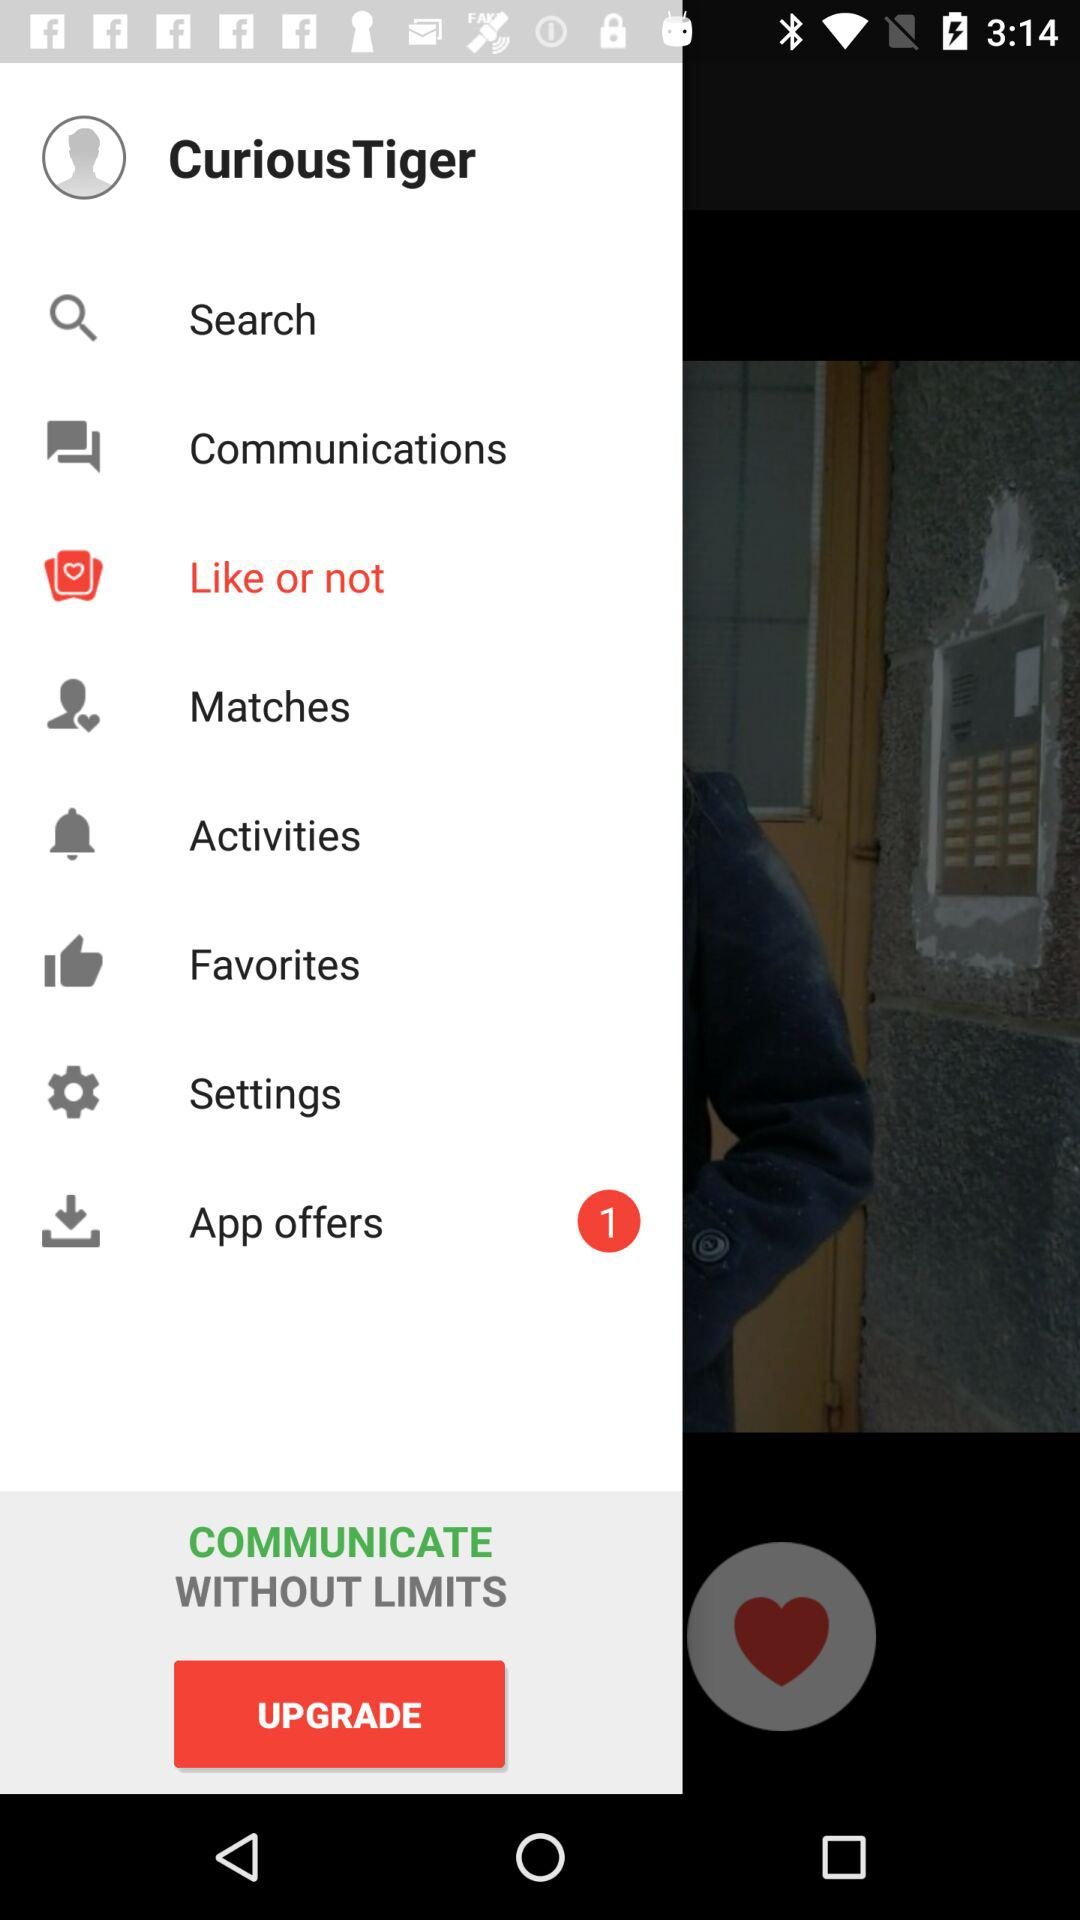Which option is selected? The selected option is "Like or not". 